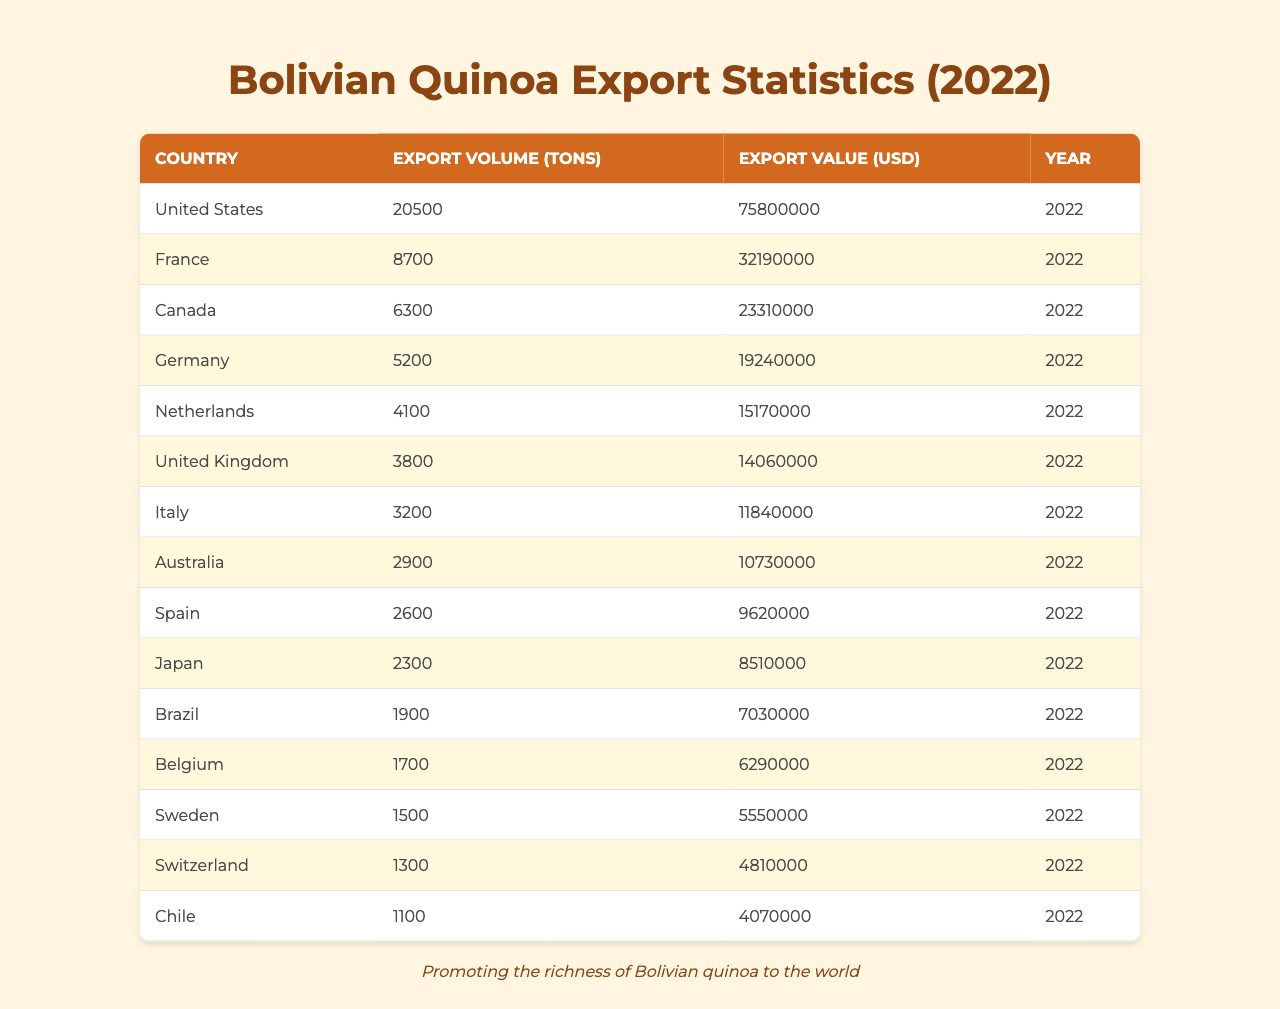What country imported the most quinoa from Bolivia in 2022? The table shows that the United States has the highest export volume of 20,500 tons of quinoa from Bolivia in 2022.
Answer: United States What is the total export volume of quinoa to France and Canada combined? The export volume to France is 8,700 tons and to Canada is 6,300 tons. Adding these together gives 8,700 + 6,300 = 15,000 tons.
Answer: 15,000 tons Did Bolivia export more quinoa to Germany than to the United Kingdom in 2022? The table states that Germany received 5,200 tons of quinoa while the United Kingdom received 3,800 tons, showing that Germany imported more.
Answer: Yes What is the total export value of quinoa to the top three importing countries? The top three countries by export volume are the United States (75,800,000 USD), France (32,190,000 USD), and Canada (23,310,000 USD). Summing these values gives 75,800,000 + 32,190,000 + 23,310,000 = 131,300,000 USD.
Answer: 131,300,000 USD What percentage of the total export volume does the Netherlands represent? The total export volume is 20,500 + 8,700 + 6,300 + 5,200 + 4,100 + 3,800 + 3,200 + 2,900 + 2,600 + 2,300 + 1,900 + 1,700 + 1,500 + 1,300 + 1,100 = 78,000 tons. The Netherlands exported 4,100 tons. Thus, (4,100 / 78,000) * 100 ≈ 5.26%.
Answer: Approximately 5.26% Which country had the highest export value per ton? To find the highest value per ton, divide the export value by the export volume for each country. For example, the United States has 75,800,000 / 20,500 ≈ 3,693 USD/ton. Following this for all countries reveals that the highest is France with 3,691 USD/ton.
Answer: France 